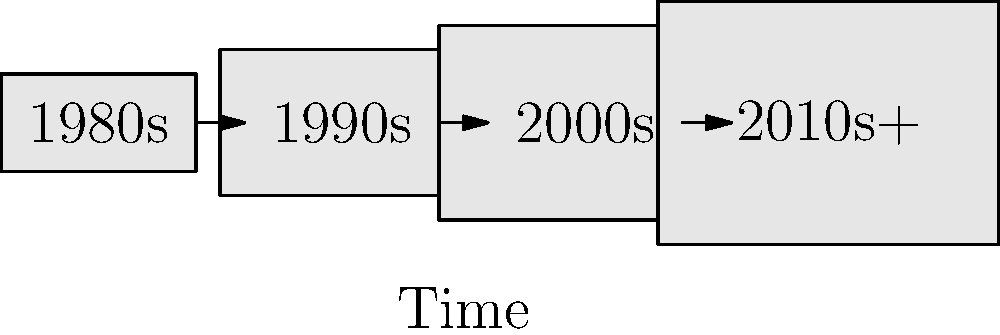Based on the diagram showing the evolution of video game controllers over time, which characteristic is most evident in the progression from the 1980s to the 2010s and beyond? To answer this question, let's analyze the diagram step-by-step:

1. The diagram shows four controller representations, each labeled with a decade from the 1980s to 2010s+.

2. As we move from left to right (representing the passage of time), we can observe several changes:

   a) Size: The controllers appear to increase in size from left to right.
   b) Shape: The controllers become slightly more complex in shape, though this is subtle in the simplified diagram.
   c) Complexity: This is implied by the increasing size and potential for more buttons/features.

3. The vertical axis is labeled "Complexity," indicating that this is a key factor being represented.

4. The horizontal axis is labeled "Time," confirming that we're looking at a progression over decades.

5. The arrows between each controller representation suggest a continuous evolution rather than abrupt changes.

6. The most noticeable and consistent change across all four representations is the increase in size, which in the context of video game controllers, typically correlates with increased complexity (more buttons, features, ergonomic design, etc.).

Given these observations, the most evident characteristic in the progression from the 1980s to the 2010s and beyond is the increase in complexity of video game controllers.
Answer: Increasing complexity 